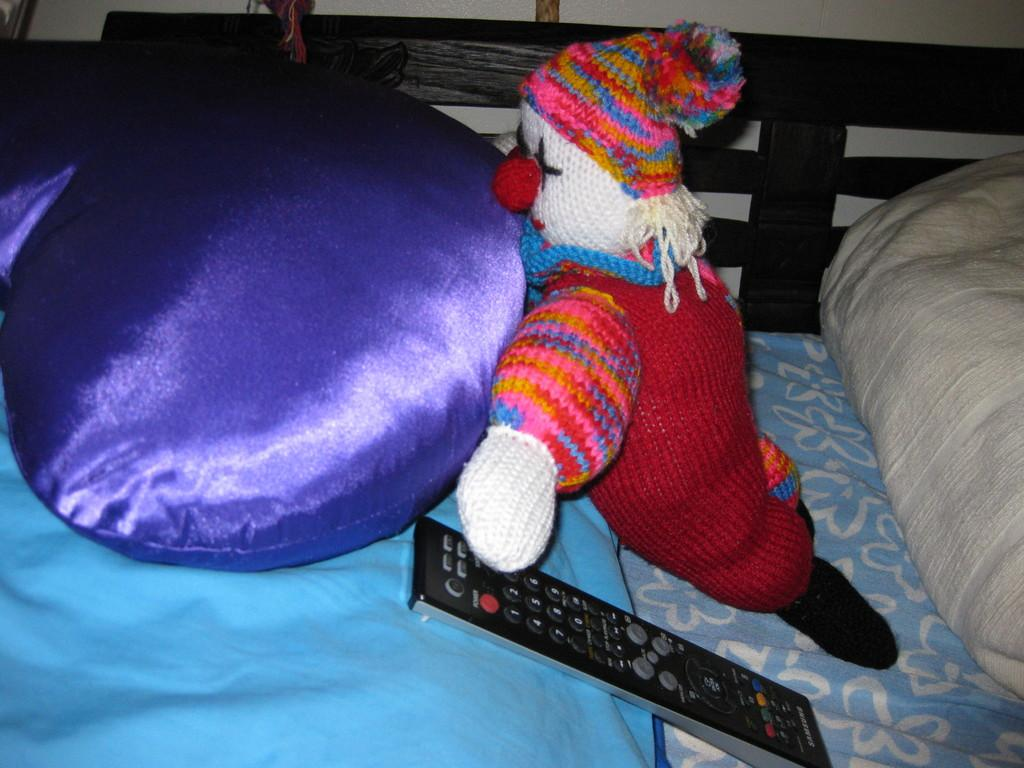What device can be seen in the image? There is a remote control in the image. What type of furniture or accessory is present in the image? There is a pillow in the image. What type of toy is visible in the image? There is a doll in the image. Can you describe any other objects in the image? There are other objects in the image, but their specific details are not mentioned in the provided facts. What type of ring is being worn by the doll in the image? There is no ring mentioned or visible in the image. The doll does not have any accessories, including a ring. 